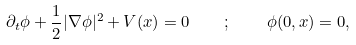Convert formula to latex. <formula><loc_0><loc_0><loc_500><loc_500>\partial _ { t } \phi + \frac { 1 } { 2 } | \nabla \phi | ^ { 2 } + V ( x ) = 0 \quad ; \quad \phi ( 0 , x ) = 0 ,</formula> 